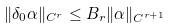Convert formula to latex. <formula><loc_0><loc_0><loc_500><loc_500>\| \delta _ { 0 } \alpha \| _ { C ^ { r } } \leq B _ { r } \| \alpha \| _ { C ^ { r + 1 } }</formula> 